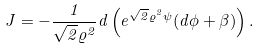Convert formula to latex. <formula><loc_0><loc_0><loc_500><loc_500>J = - { \frac { 1 } { \sqrt { 2 } \varrho ^ { 2 } } } d \left ( e ^ { \sqrt { 2 } \varrho ^ { 2 } \psi } ( d \phi + \beta ) \right ) .</formula> 